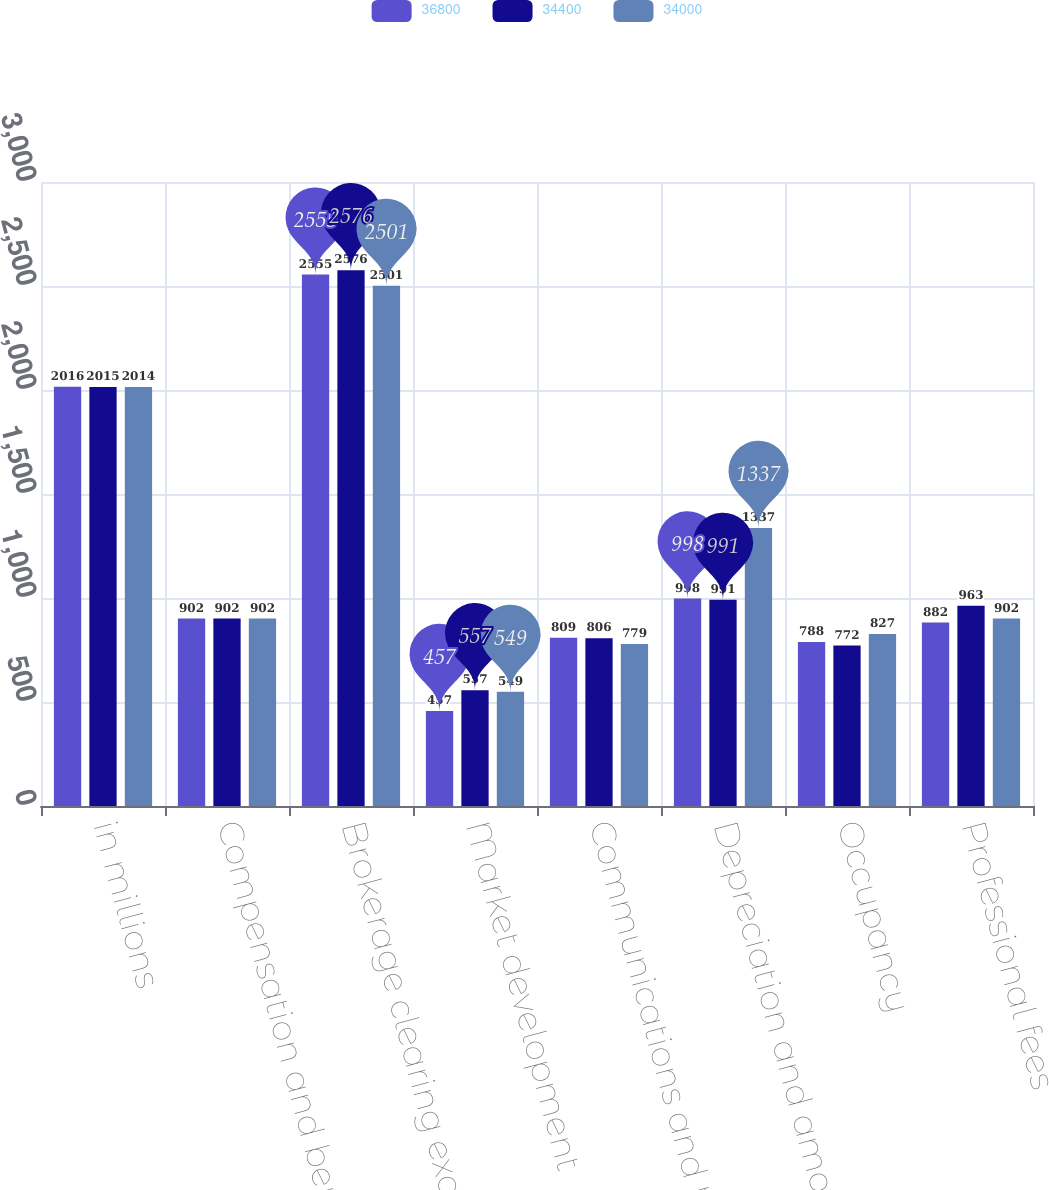<chart> <loc_0><loc_0><loc_500><loc_500><stacked_bar_chart><ecel><fcel>in millions<fcel>Compensation and benefits<fcel>Brokerage clearing exchange<fcel>Market development<fcel>Communications and technology<fcel>Depreciation and amortization<fcel>Occupancy<fcel>Professional fees<nl><fcel>36800<fcel>2016<fcel>902<fcel>2555<fcel>457<fcel>809<fcel>998<fcel>788<fcel>882<nl><fcel>34400<fcel>2015<fcel>902<fcel>2576<fcel>557<fcel>806<fcel>991<fcel>772<fcel>963<nl><fcel>34000<fcel>2014<fcel>902<fcel>2501<fcel>549<fcel>779<fcel>1337<fcel>827<fcel>902<nl></chart> 